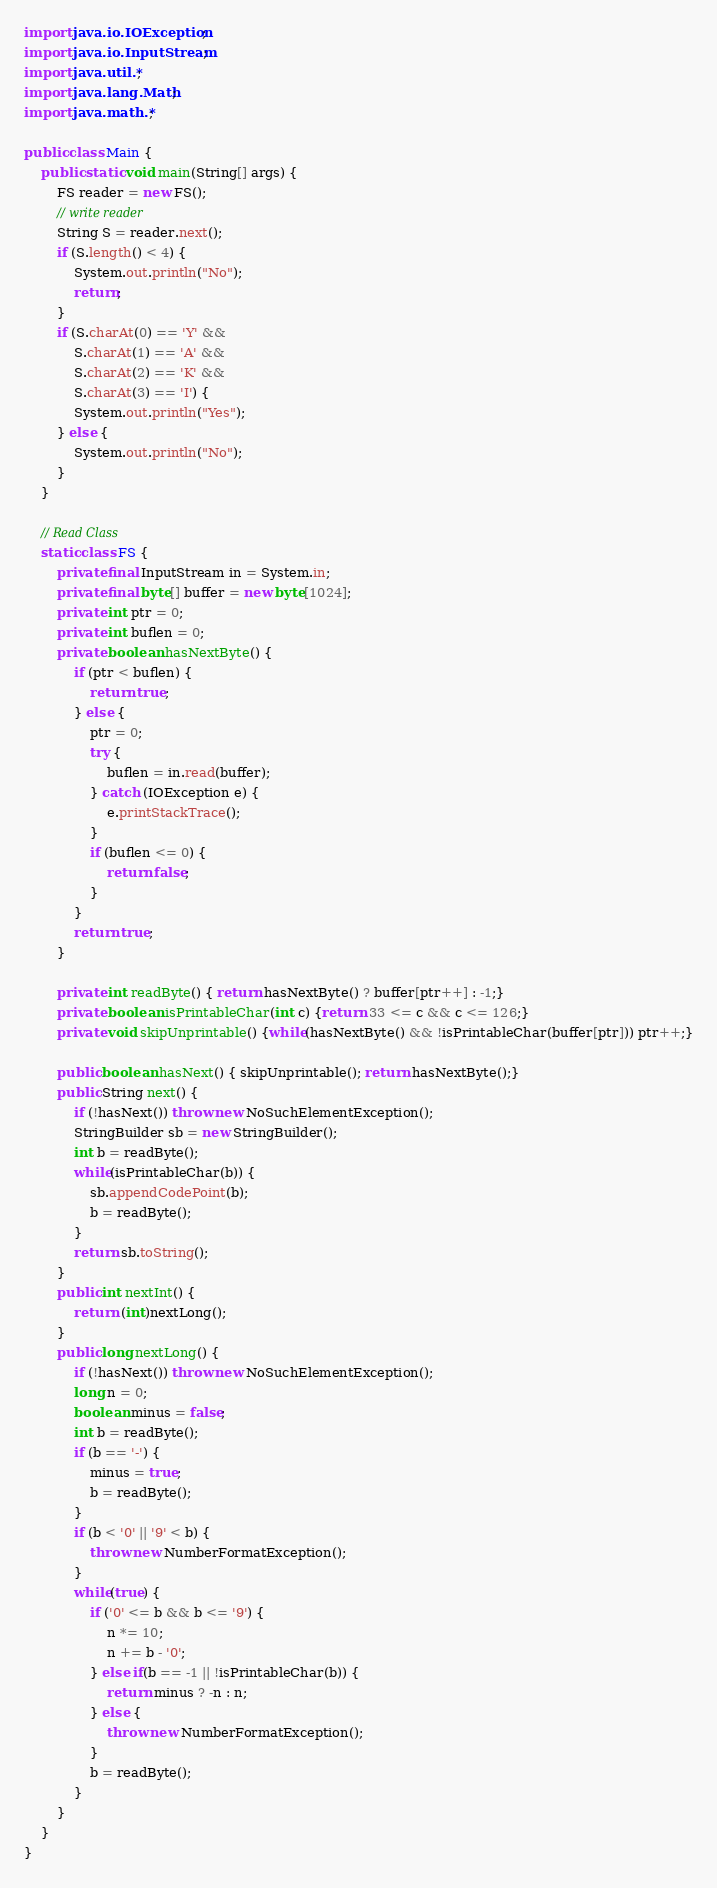<code> <loc_0><loc_0><loc_500><loc_500><_Java_>import java.io.IOException;
import java.io.InputStream;
import java.util.*;
import java.lang.Math;
import java.math.*;

public class Main {
    public static void main(String[] args) {
        FS reader = new FS();
        // write reader
        String S = reader.next();
        if (S.length() < 4) {
            System.out.println("No");
            return;
        }
        if (S.charAt(0) == 'Y' &&
            S.charAt(1) == 'A' &&
            S.charAt(2) == 'K' &&
            S.charAt(3) == 'I') {
            System.out.println("Yes");
        } else {
            System.out.println("No");
        }
    }

    // Read Class
    static class FS {
        private final InputStream in = System.in;
        private final byte[] buffer = new byte[1024];
        private int ptr = 0;
        private int buflen = 0;
        private boolean hasNextByte() {
            if (ptr < buflen) {
                return true;
            } else {
                ptr = 0;
                try {
                    buflen = in.read(buffer);
                } catch (IOException e) {
                    e.printStackTrace();
                }
                if (buflen <= 0) {
                    return false;
                }
            }
            return true;
        }
    
        private int readByte() { return hasNextByte() ? buffer[ptr++] : -1;}
        private boolean isPrintableChar(int c) {return 33 <= c && c <= 126;}
        private void skipUnprintable() {while(hasNextByte() && !isPrintableChar(buffer[ptr])) ptr++;}
    
        public boolean hasNext() { skipUnprintable(); return hasNextByte();}
        public String next() {
            if (!hasNext()) throw new NoSuchElementException();
            StringBuilder sb = new StringBuilder();
            int b = readByte();
            while(isPrintableChar(b)) {
                sb.appendCodePoint(b);
                b = readByte();
            }
            return sb.toString();
        }
        public int nextInt() {
            return (int)nextLong();
        }
        public long nextLong() {
            if (!hasNext()) throw new NoSuchElementException();
            long n = 0;
            boolean minus = false;
            int b = readByte();
            if (b == '-') {
                minus = true;
                b = readByte();
            }
            if (b < '0' || '9' < b) {
                throw new NumberFormatException();
            }
            while(true) {
                if ('0' <= b && b <= '9') {
                    n *= 10;
                    n += b - '0';
                } else if(b == -1 || !isPrintableChar(b)) {
                    return minus ? -n : n;
                } else {
                    throw new NumberFormatException();
                }
                b = readByte();
            }
        }
    }
}

</code> 